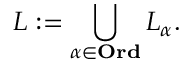<formula> <loc_0><loc_0><loc_500><loc_500>L \colon = \bigcup _ { \alpha \in O r d } L _ { \alpha } .</formula> 